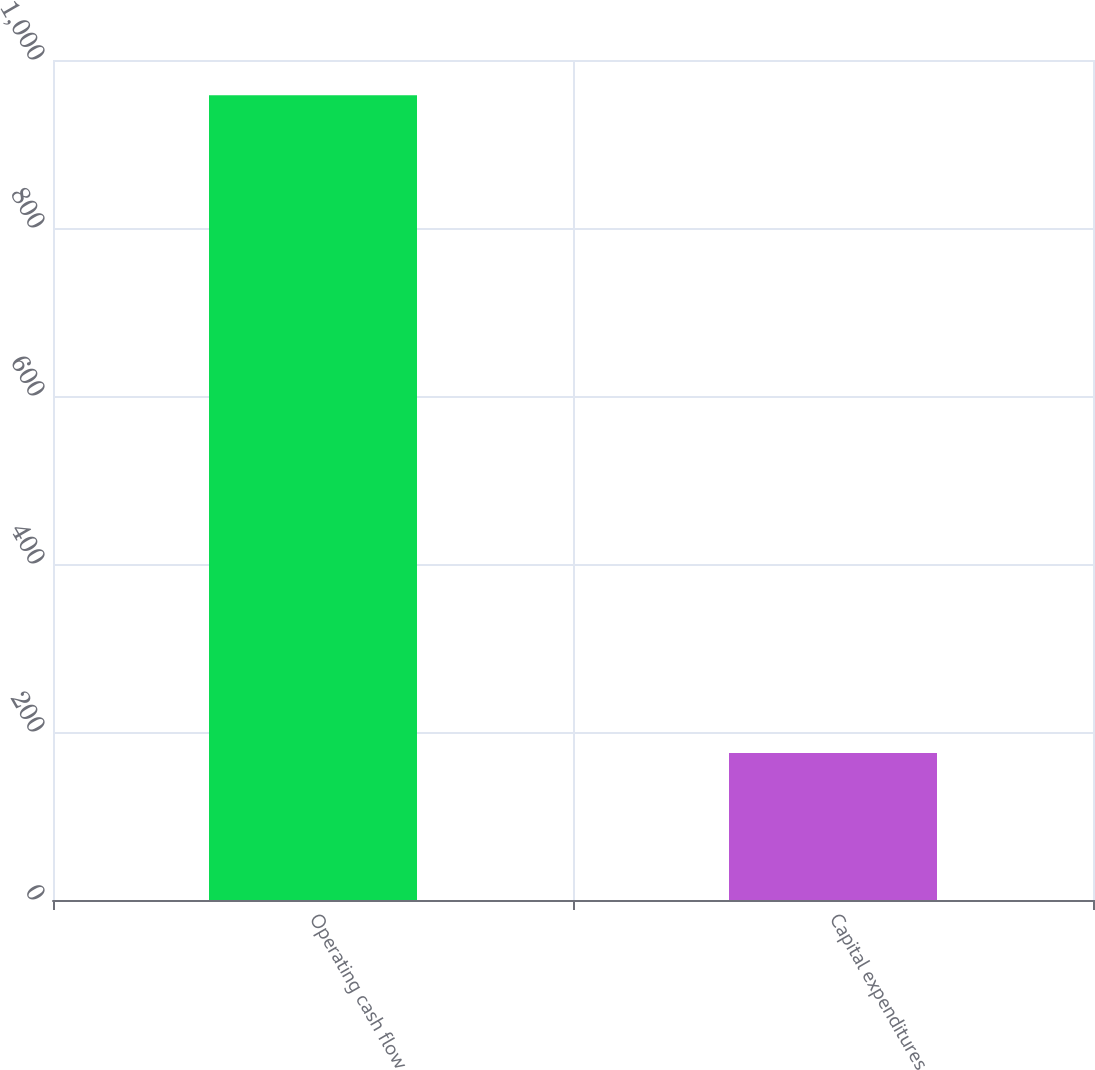Convert chart to OTSL. <chart><loc_0><loc_0><loc_500><loc_500><bar_chart><fcel>Operating cash flow<fcel>Capital expenditures<nl><fcel>958<fcel>175<nl></chart> 